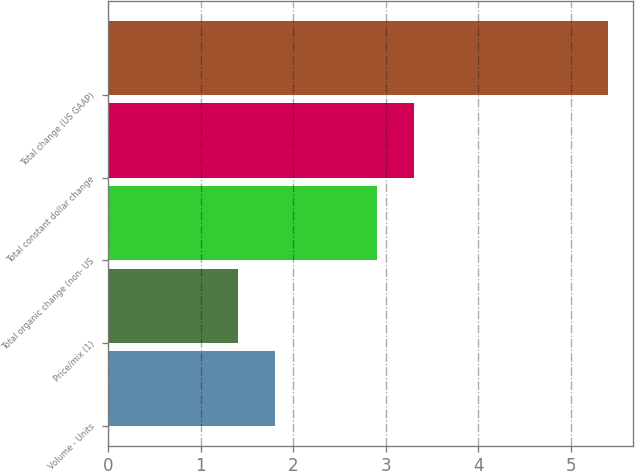<chart> <loc_0><loc_0><loc_500><loc_500><bar_chart><fcel>Volume - Units<fcel>Price/mix (1)<fcel>Total organic change (non- US<fcel>Total constant dollar change<fcel>Total change (US GAAP)<nl><fcel>1.8<fcel>1.4<fcel>2.9<fcel>3.3<fcel>5.4<nl></chart> 